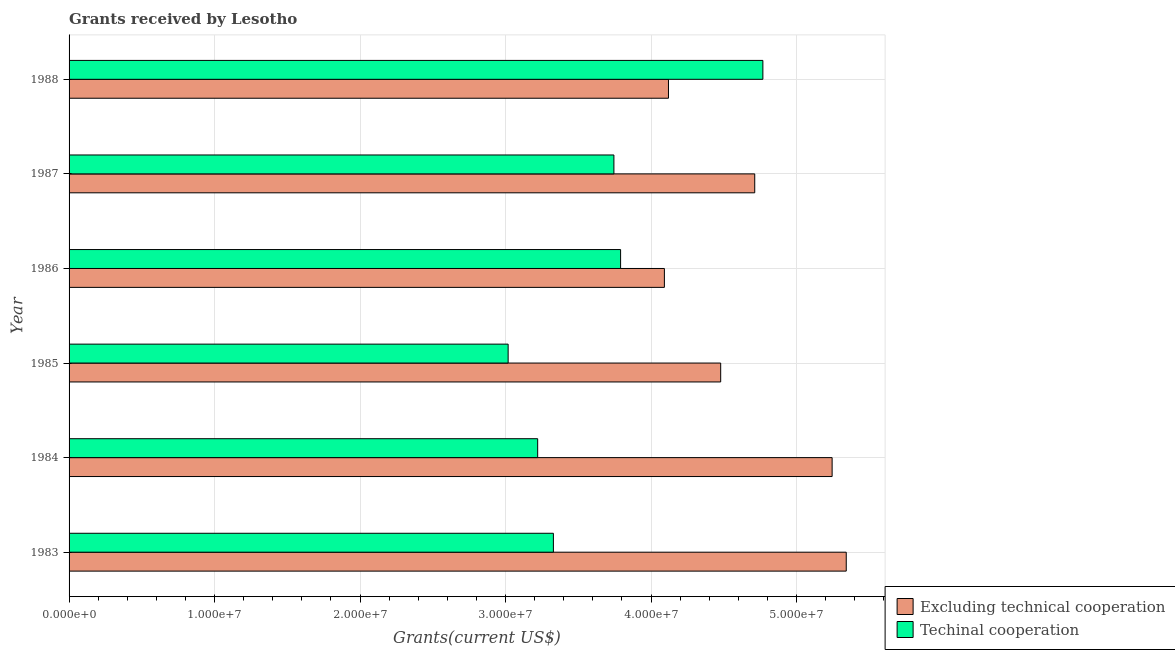Are the number of bars per tick equal to the number of legend labels?
Offer a terse response. Yes. How many bars are there on the 2nd tick from the bottom?
Make the answer very short. 2. In how many cases, is the number of bars for a given year not equal to the number of legend labels?
Offer a terse response. 0. What is the amount of grants received(including technical cooperation) in 1988?
Offer a terse response. 4.77e+07. Across all years, what is the maximum amount of grants received(including technical cooperation)?
Provide a short and direct response. 4.77e+07. Across all years, what is the minimum amount of grants received(including technical cooperation)?
Your answer should be compact. 3.02e+07. What is the total amount of grants received(including technical cooperation) in the graph?
Give a very brief answer. 2.19e+08. What is the difference between the amount of grants received(excluding technical cooperation) in 1984 and that in 1987?
Your answer should be compact. 5.32e+06. What is the difference between the amount of grants received(excluding technical cooperation) in 1985 and the amount of grants received(including technical cooperation) in 1984?
Your answer should be compact. 1.26e+07. What is the average amount of grants received(including technical cooperation) per year?
Keep it short and to the point. 3.65e+07. In the year 1988, what is the difference between the amount of grants received(excluding technical cooperation) and amount of grants received(including technical cooperation)?
Your answer should be compact. -6.49e+06. What is the difference between the highest and the second highest amount of grants received(excluding technical cooperation)?
Provide a short and direct response. 9.70e+05. What is the difference between the highest and the lowest amount of grants received(including technical cooperation)?
Offer a terse response. 1.75e+07. What does the 2nd bar from the top in 1986 represents?
Offer a terse response. Excluding technical cooperation. What does the 1st bar from the bottom in 1984 represents?
Give a very brief answer. Excluding technical cooperation. How many bars are there?
Your answer should be very brief. 12. What is the difference between two consecutive major ticks on the X-axis?
Provide a short and direct response. 1.00e+07. Does the graph contain any zero values?
Provide a short and direct response. No. Where does the legend appear in the graph?
Your response must be concise. Bottom right. How many legend labels are there?
Give a very brief answer. 2. How are the legend labels stacked?
Your response must be concise. Vertical. What is the title of the graph?
Offer a very short reply. Grants received by Lesotho. Does "Urban" appear as one of the legend labels in the graph?
Keep it short and to the point. No. What is the label or title of the X-axis?
Ensure brevity in your answer.  Grants(current US$). What is the label or title of the Y-axis?
Provide a succinct answer. Year. What is the Grants(current US$) in Excluding technical cooperation in 1983?
Ensure brevity in your answer.  5.34e+07. What is the Grants(current US$) of Techinal cooperation in 1983?
Make the answer very short. 3.33e+07. What is the Grants(current US$) in Excluding technical cooperation in 1984?
Provide a succinct answer. 5.24e+07. What is the Grants(current US$) in Techinal cooperation in 1984?
Provide a short and direct response. 3.22e+07. What is the Grants(current US$) in Excluding technical cooperation in 1985?
Ensure brevity in your answer.  4.48e+07. What is the Grants(current US$) of Techinal cooperation in 1985?
Your answer should be compact. 3.02e+07. What is the Grants(current US$) of Excluding technical cooperation in 1986?
Your answer should be very brief. 4.09e+07. What is the Grants(current US$) of Techinal cooperation in 1986?
Provide a short and direct response. 3.79e+07. What is the Grants(current US$) of Excluding technical cooperation in 1987?
Provide a succinct answer. 4.71e+07. What is the Grants(current US$) in Techinal cooperation in 1987?
Provide a short and direct response. 3.74e+07. What is the Grants(current US$) of Excluding technical cooperation in 1988?
Keep it short and to the point. 4.12e+07. What is the Grants(current US$) in Techinal cooperation in 1988?
Your answer should be compact. 4.77e+07. Across all years, what is the maximum Grants(current US$) in Excluding technical cooperation?
Ensure brevity in your answer.  5.34e+07. Across all years, what is the maximum Grants(current US$) in Techinal cooperation?
Your answer should be very brief. 4.77e+07. Across all years, what is the minimum Grants(current US$) of Excluding technical cooperation?
Keep it short and to the point. 4.09e+07. Across all years, what is the minimum Grants(current US$) in Techinal cooperation?
Keep it short and to the point. 3.02e+07. What is the total Grants(current US$) of Excluding technical cooperation in the graph?
Your answer should be compact. 2.80e+08. What is the total Grants(current US$) in Techinal cooperation in the graph?
Your response must be concise. 2.19e+08. What is the difference between the Grants(current US$) in Excluding technical cooperation in 1983 and that in 1984?
Make the answer very short. 9.70e+05. What is the difference between the Grants(current US$) in Techinal cooperation in 1983 and that in 1984?
Ensure brevity in your answer.  1.08e+06. What is the difference between the Grants(current US$) in Excluding technical cooperation in 1983 and that in 1985?
Make the answer very short. 8.63e+06. What is the difference between the Grants(current US$) in Techinal cooperation in 1983 and that in 1985?
Offer a terse response. 3.11e+06. What is the difference between the Grants(current US$) of Excluding technical cooperation in 1983 and that in 1986?
Keep it short and to the point. 1.25e+07. What is the difference between the Grants(current US$) of Techinal cooperation in 1983 and that in 1986?
Your answer should be very brief. -4.62e+06. What is the difference between the Grants(current US$) in Excluding technical cooperation in 1983 and that in 1987?
Provide a short and direct response. 6.29e+06. What is the difference between the Grants(current US$) of Techinal cooperation in 1983 and that in 1987?
Offer a very short reply. -4.16e+06. What is the difference between the Grants(current US$) of Excluding technical cooperation in 1983 and that in 1988?
Keep it short and to the point. 1.22e+07. What is the difference between the Grants(current US$) of Techinal cooperation in 1983 and that in 1988?
Provide a short and direct response. -1.44e+07. What is the difference between the Grants(current US$) in Excluding technical cooperation in 1984 and that in 1985?
Offer a terse response. 7.66e+06. What is the difference between the Grants(current US$) of Techinal cooperation in 1984 and that in 1985?
Make the answer very short. 2.03e+06. What is the difference between the Grants(current US$) in Excluding technical cooperation in 1984 and that in 1986?
Offer a very short reply. 1.15e+07. What is the difference between the Grants(current US$) of Techinal cooperation in 1984 and that in 1986?
Offer a very short reply. -5.70e+06. What is the difference between the Grants(current US$) in Excluding technical cooperation in 1984 and that in 1987?
Your response must be concise. 5.32e+06. What is the difference between the Grants(current US$) of Techinal cooperation in 1984 and that in 1987?
Your answer should be very brief. -5.24e+06. What is the difference between the Grants(current US$) in Excluding technical cooperation in 1984 and that in 1988?
Your answer should be very brief. 1.12e+07. What is the difference between the Grants(current US$) of Techinal cooperation in 1984 and that in 1988?
Keep it short and to the point. -1.55e+07. What is the difference between the Grants(current US$) of Excluding technical cooperation in 1985 and that in 1986?
Ensure brevity in your answer.  3.87e+06. What is the difference between the Grants(current US$) in Techinal cooperation in 1985 and that in 1986?
Offer a very short reply. -7.73e+06. What is the difference between the Grants(current US$) in Excluding technical cooperation in 1985 and that in 1987?
Make the answer very short. -2.34e+06. What is the difference between the Grants(current US$) in Techinal cooperation in 1985 and that in 1987?
Your response must be concise. -7.27e+06. What is the difference between the Grants(current US$) in Excluding technical cooperation in 1985 and that in 1988?
Make the answer very short. 3.59e+06. What is the difference between the Grants(current US$) in Techinal cooperation in 1985 and that in 1988?
Make the answer very short. -1.75e+07. What is the difference between the Grants(current US$) of Excluding technical cooperation in 1986 and that in 1987?
Your answer should be compact. -6.21e+06. What is the difference between the Grants(current US$) in Techinal cooperation in 1986 and that in 1987?
Make the answer very short. 4.60e+05. What is the difference between the Grants(current US$) of Excluding technical cooperation in 1986 and that in 1988?
Make the answer very short. -2.80e+05. What is the difference between the Grants(current US$) in Techinal cooperation in 1986 and that in 1988?
Your answer should be very brief. -9.78e+06. What is the difference between the Grants(current US$) in Excluding technical cooperation in 1987 and that in 1988?
Your answer should be very brief. 5.93e+06. What is the difference between the Grants(current US$) of Techinal cooperation in 1987 and that in 1988?
Your answer should be compact. -1.02e+07. What is the difference between the Grants(current US$) in Excluding technical cooperation in 1983 and the Grants(current US$) in Techinal cooperation in 1984?
Your response must be concise. 2.12e+07. What is the difference between the Grants(current US$) of Excluding technical cooperation in 1983 and the Grants(current US$) of Techinal cooperation in 1985?
Give a very brief answer. 2.32e+07. What is the difference between the Grants(current US$) in Excluding technical cooperation in 1983 and the Grants(current US$) in Techinal cooperation in 1986?
Offer a very short reply. 1.55e+07. What is the difference between the Grants(current US$) of Excluding technical cooperation in 1983 and the Grants(current US$) of Techinal cooperation in 1987?
Give a very brief answer. 1.60e+07. What is the difference between the Grants(current US$) in Excluding technical cooperation in 1983 and the Grants(current US$) in Techinal cooperation in 1988?
Provide a short and direct response. 5.73e+06. What is the difference between the Grants(current US$) of Excluding technical cooperation in 1984 and the Grants(current US$) of Techinal cooperation in 1985?
Give a very brief answer. 2.23e+07. What is the difference between the Grants(current US$) in Excluding technical cooperation in 1984 and the Grants(current US$) in Techinal cooperation in 1986?
Your response must be concise. 1.45e+07. What is the difference between the Grants(current US$) in Excluding technical cooperation in 1984 and the Grants(current US$) in Techinal cooperation in 1987?
Offer a very short reply. 1.50e+07. What is the difference between the Grants(current US$) in Excluding technical cooperation in 1984 and the Grants(current US$) in Techinal cooperation in 1988?
Offer a very short reply. 4.76e+06. What is the difference between the Grants(current US$) in Excluding technical cooperation in 1985 and the Grants(current US$) in Techinal cooperation in 1986?
Your answer should be very brief. 6.88e+06. What is the difference between the Grants(current US$) of Excluding technical cooperation in 1985 and the Grants(current US$) of Techinal cooperation in 1987?
Provide a short and direct response. 7.34e+06. What is the difference between the Grants(current US$) in Excluding technical cooperation in 1985 and the Grants(current US$) in Techinal cooperation in 1988?
Ensure brevity in your answer.  -2.90e+06. What is the difference between the Grants(current US$) of Excluding technical cooperation in 1986 and the Grants(current US$) of Techinal cooperation in 1987?
Provide a short and direct response. 3.47e+06. What is the difference between the Grants(current US$) of Excluding technical cooperation in 1986 and the Grants(current US$) of Techinal cooperation in 1988?
Provide a succinct answer. -6.77e+06. What is the difference between the Grants(current US$) of Excluding technical cooperation in 1987 and the Grants(current US$) of Techinal cooperation in 1988?
Keep it short and to the point. -5.60e+05. What is the average Grants(current US$) in Excluding technical cooperation per year?
Your answer should be very brief. 4.67e+07. What is the average Grants(current US$) of Techinal cooperation per year?
Your answer should be very brief. 3.65e+07. In the year 1983, what is the difference between the Grants(current US$) of Excluding technical cooperation and Grants(current US$) of Techinal cooperation?
Your answer should be very brief. 2.01e+07. In the year 1984, what is the difference between the Grants(current US$) in Excluding technical cooperation and Grants(current US$) in Techinal cooperation?
Provide a succinct answer. 2.02e+07. In the year 1985, what is the difference between the Grants(current US$) in Excluding technical cooperation and Grants(current US$) in Techinal cooperation?
Give a very brief answer. 1.46e+07. In the year 1986, what is the difference between the Grants(current US$) in Excluding technical cooperation and Grants(current US$) in Techinal cooperation?
Your answer should be very brief. 3.01e+06. In the year 1987, what is the difference between the Grants(current US$) of Excluding technical cooperation and Grants(current US$) of Techinal cooperation?
Give a very brief answer. 9.68e+06. In the year 1988, what is the difference between the Grants(current US$) of Excluding technical cooperation and Grants(current US$) of Techinal cooperation?
Your answer should be very brief. -6.49e+06. What is the ratio of the Grants(current US$) in Excluding technical cooperation in 1983 to that in 1984?
Provide a succinct answer. 1.02. What is the ratio of the Grants(current US$) in Techinal cooperation in 1983 to that in 1984?
Offer a terse response. 1.03. What is the ratio of the Grants(current US$) in Excluding technical cooperation in 1983 to that in 1985?
Offer a very short reply. 1.19. What is the ratio of the Grants(current US$) in Techinal cooperation in 1983 to that in 1985?
Your answer should be compact. 1.1. What is the ratio of the Grants(current US$) of Excluding technical cooperation in 1983 to that in 1986?
Your answer should be very brief. 1.31. What is the ratio of the Grants(current US$) in Techinal cooperation in 1983 to that in 1986?
Provide a succinct answer. 0.88. What is the ratio of the Grants(current US$) in Excluding technical cooperation in 1983 to that in 1987?
Your response must be concise. 1.13. What is the ratio of the Grants(current US$) of Excluding technical cooperation in 1983 to that in 1988?
Offer a terse response. 1.3. What is the ratio of the Grants(current US$) of Techinal cooperation in 1983 to that in 1988?
Provide a succinct answer. 0.7. What is the ratio of the Grants(current US$) of Excluding technical cooperation in 1984 to that in 1985?
Your answer should be compact. 1.17. What is the ratio of the Grants(current US$) of Techinal cooperation in 1984 to that in 1985?
Offer a terse response. 1.07. What is the ratio of the Grants(current US$) in Excluding technical cooperation in 1984 to that in 1986?
Offer a very short reply. 1.28. What is the ratio of the Grants(current US$) of Techinal cooperation in 1984 to that in 1986?
Your answer should be compact. 0.85. What is the ratio of the Grants(current US$) of Excluding technical cooperation in 1984 to that in 1987?
Provide a short and direct response. 1.11. What is the ratio of the Grants(current US$) in Techinal cooperation in 1984 to that in 1987?
Your answer should be compact. 0.86. What is the ratio of the Grants(current US$) of Excluding technical cooperation in 1984 to that in 1988?
Ensure brevity in your answer.  1.27. What is the ratio of the Grants(current US$) in Techinal cooperation in 1984 to that in 1988?
Make the answer very short. 0.68. What is the ratio of the Grants(current US$) of Excluding technical cooperation in 1985 to that in 1986?
Ensure brevity in your answer.  1.09. What is the ratio of the Grants(current US$) of Techinal cooperation in 1985 to that in 1986?
Offer a very short reply. 0.8. What is the ratio of the Grants(current US$) in Excluding technical cooperation in 1985 to that in 1987?
Provide a succinct answer. 0.95. What is the ratio of the Grants(current US$) in Techinal cooperation in 1985 to that in 1987?
Ensure brevity in your answer.  0.81. What is the ratio of the Grants(current US$) in Excluding technical cooperation in 1985 to that in 1988?
Make the answer very short. 1.09. What is the ratio of the Grants(current US$) in Techinal cooperation in 1985 to that in 1988?
Offer a terse response. 0.63. What is the ratio of the Grants(current US$) in Excluding technical cooperation in 1986 to that in 1987?
Ensure brevity in your answer.  0.87. What is the ratio of the Grants(current US$) in Techinal cooperation in 1986 to that in 1987?
Offer a terse response. 1.01. What is the ratio of the Grants(current US$) in Excluding technical cooperation in 1986 to that in 1988?
Your response must be concise. 0.99. What is the ratio of the Grants(current US$) in Techinal cooperation in 1986 to that in 1988?
Make the answer very short. 0.79. What is the ratio of the Grants(current US$) of Excluding technical cooperation in 1987 to that in 1988?
Provide a short and direct response. 1.14. What is the ratio of the Grants(current US$) in Techinal cooperation in 1987 to that in 1988?
Provide a succinct answer. 0.79. What is the difference between the highest and the second highest Grants(current US$) of Excluding technical cooperation?
Your answer should be very brief. 9.70e+05. What is the difference between the highest and the second highest Grants(current US$) in Techinal cooperation?
Provide a short and direct response. 9.78e+06. What is the difference between the highest and the lowest Grants(current US$) in Excluding technical cooperation?
Ensure brevity in your answer.  1.25e+07. What is the difference between the highest and the lowest Grants(current US$) of Techinal cooperation?
Keep it short and to the point. 1.75e+07. 